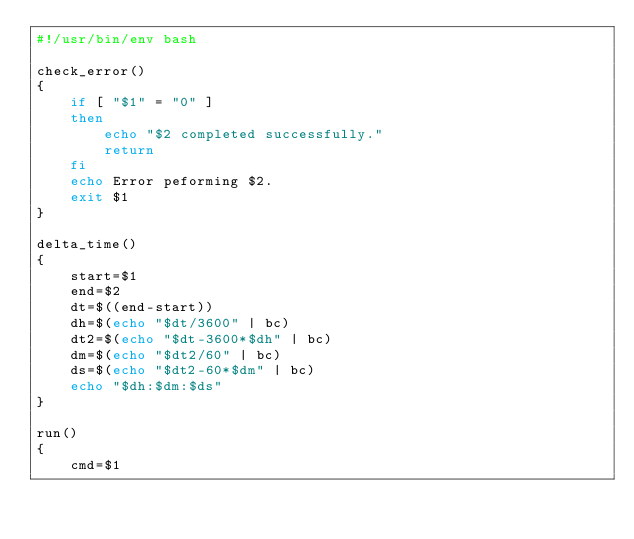<code> <loc_0><loc_0><loc_500><loc_500><_Bash_>#!/usr/bin/env bash

check_error()
{
    if [ "$1" = "0" ]
    then
        echo "$2 completed successfully."
        return
    fi
    echo Error peforming $2.
    exit $1
}

delta_time()
{
    start=$1
    end=$2
    dt=$((end-start))
    dh=$(echo "$dt/3600" | bc)
    dt2=$(echo "$dt-3600*$dh" | bc)
    dm=$(echo "$dt2/60" | bc)
    ds=$(echo "$dt2-60*$dm" | bc)
    echo "$dh:$dm:$ds"
}

run()
{
    cmd=$1</code> 